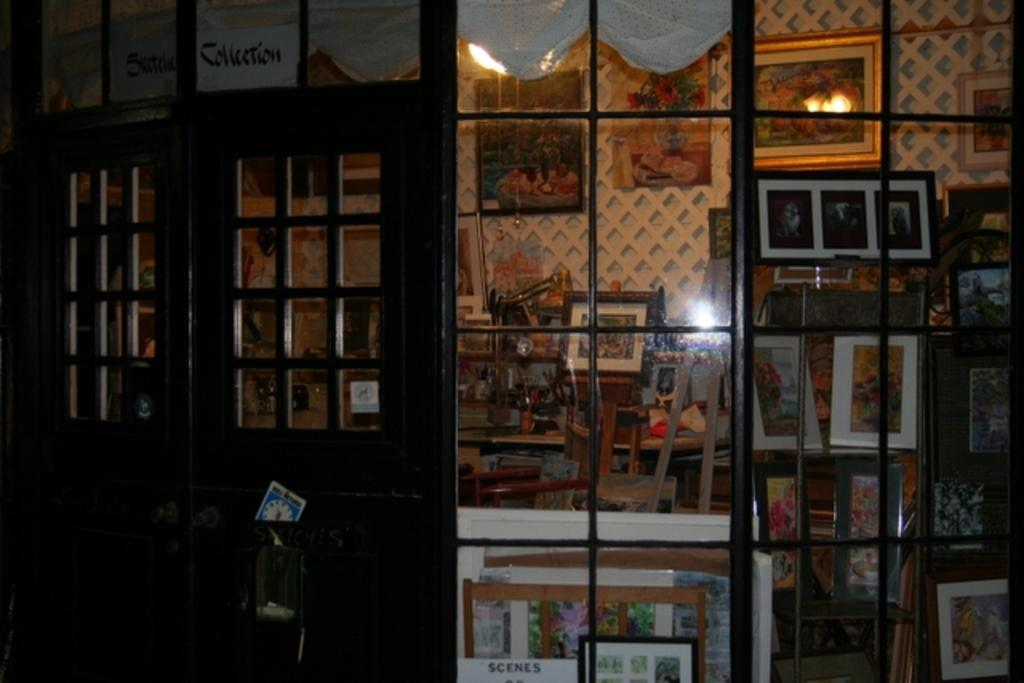What is located on the left side of the image? There is a door on the left side of the image. What can be seen on the right side of the image? There are lights, chairs, and photo frames on the wall on the right side of the image. Are there any photo frames visible in the image that are not on the wall? Yes, there are photo frames on the racks. How does the sock increase in size in the image? There is no sock present in the image, so it cannot increase in size. 